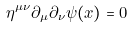<formula> <loc_0><loc_0><loc_500><loc_500>\eta ^ { \mu \nu } \partial _ { \mu } \partial _ { \nu } \psi ( x ) = 0</formula> 